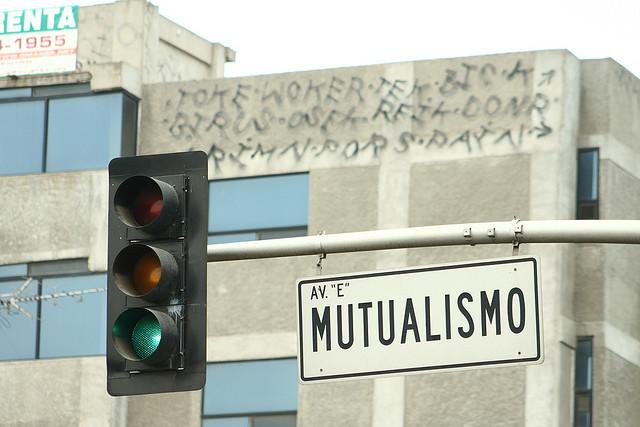What is written on the wall?
Write a very short answer. Tokewokertekbckbrusosekriedonrrimnporspayn. What is the name of the Avenue?
Short answer required. Mutualismo. What color is the light?
Concise answer only. Green. 